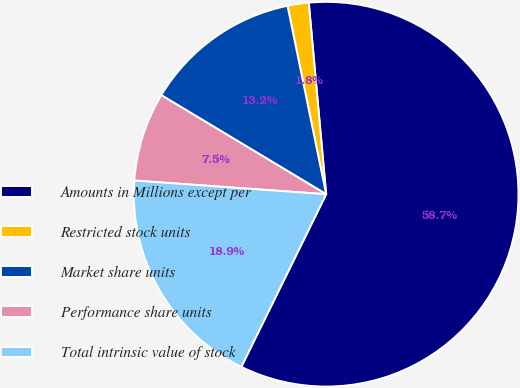Convert chart. <chart><loc_0><loc_0><loc_500><loc_500><pie_chart><fcel>Amounts in Millions except per<fcel>Restricted stock units<fcel>Market share units<fcel>Performance share units<fcel>Total intrinsic value of stock<nl><fcel>58.71%<fcel>1.78%<fcel>13.17%<fcel>7.48%<fcel>18.86%<nl></chart> 